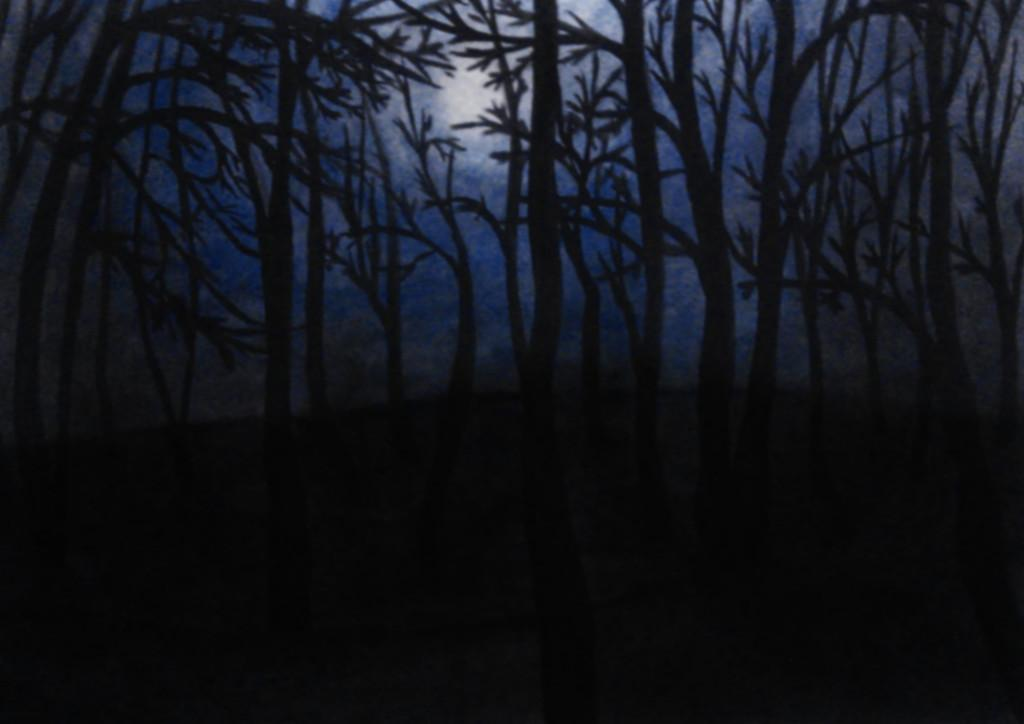What type of vegetation can be seen in the image? There are trees in the image. What is visible in the background of the image? There is a sky visible in the background of the image. What can be observed in the sky? Clouds are present in the sky. How would you describe the lighting conditions in the image? The image was taken in dim light. What type of fruit is being used to make a decision in the image? There is no fruit or decision-making process depicted in the image. 